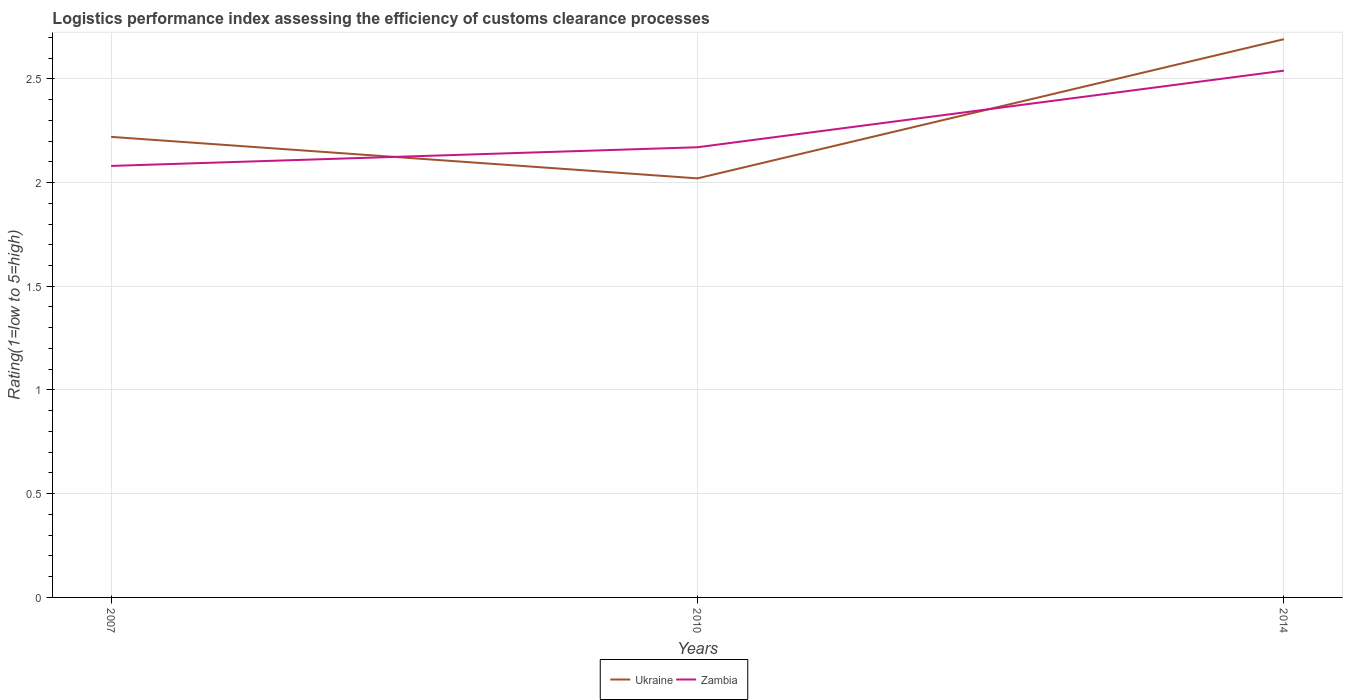How many different coloured lines are there?
Give a very brief answer. 2. Across all years, what is the maximum Logistic performance index in Ukraine?
Make the answer very short. 2.02. What is the total Logistic performance index in Zambia in the graph?
Provide a short and direct response. -0.46. What is the difference between the highest and the second highest Logistic performance index in Ukraine?
Provide a succinct answer. 0.67. What is the difference between the highest and the lowest Logistic performance index in Ukraine?
Offer a terse response. 1. Is the Logistic performance index in Zambia strictly greater than the Logistic performance index in Ukraine over the years?
Ensure brevity in your answer.  No. How many lines are there?
Make the answer very short. 2. How many years are there in the graph?
Give a very brief answer. 3. Does the graph contain any zero values?
Provide a short and direct response. No. Does the graph contain grids?
Ensure brevity in your answer.  Yes. Where does the legend appear in the graph?
Your response must be concise. Bottom center. How are the legend labels stacked?
Offer a terse response. Horizontal. What is the title of the graph?
Ensure brevity in your answer.  Logistics performance index assessing the efficiency of customs clearance processes. What is the label or title of the Y-axis?
Provide a short and direct response. Rating(1=low to 5=high). What is the Rating(1=low to 5=high) of Ukraine in 2007?
Your answer should be very brief. 2.22. What is the Rating(1=low to 5=high) in Zambia in 2007?
Your answer should be compact. 2.08. What is the Rating(1=low to 5=high) of Ukraine in 2010?
Provide a succinct answer. 2.02. What is the Rating(1=low to 5=high) in Zambia in 2010?
Offer a terse response. 2.17. What is the Rating(1=low to 5=high) of Ukraine in 2014?
Your answer should be very brief. 2.69. What is the Rating(1=low to 5=high) in Zambia in 2014?
Provide a short and direct response. 2.54. Across all years, what is the maximum Rating(1=low to 5=high) of Ukraine?
Provide a succinct answer. 2.69. Across all years, what is the maximum Rating(1=low to 5=high) of Zambia?
Your answer should be compact. 2.54. Across all years, what is the minimum Rating(1=low to 5=high) of Ukraine?
Provide a short and direct response. 2.02. Across all years, what is the minimum Rating(1=low to 5=high) in Zambia?
Offer a very short reply. 2.08. What is the total Rating(1=low to 5=high) in Ukraine in the graph?
Provide a short and direct response. 6.93. What is the total Rating(1=low to 5=high) of Zambia in the graph?
Your response must be concise. 6.79. What is the difference between the Rating(1=low to 5=high) of Ukraine in 2007 and that in 2010?
Offer a terse response. 0.2. What is the difference between the Rating(1=low to 5=high) in Zambia in 2007 and that in 2010?
Your answer should be very brief. -0.09. What is the difference between the Rating(1=low to 5=high) of Ukraine in 2007 and that in 2014?
Give a very brief answer. -0.47. What is the difference between the Rating(1=low to 5=high) of Zambia in 2007 and that in 2014?
Make the answer very short. -0.46. What is the difference between the Rating(1=low to 5=high) of Ukraine in 2010 and that in 2014?
Provide a short and direct response. -0.67. What is the difference between the Rating(1=low to 5=high) of Zambia in 2010 and that in 2014?
Give a very brief answer. -0.37. What is the difference between the Rating(1=low to 5=high) of Ukraine in 2007 and the Rating(1=low to 5=high) of Zambia in 2010?
Provide a short and direct response. 0.05. What is the difference between the Rating(1=low to 5=high) in Ukraine in 2007 and the Rating(1=low to 5=high) in Zambia in 2014?
Your response must be concise. -0.32. What is the difference between the Rating(1=low to 5=high) in Ukraine in 2010 and the Rating(1=low to 5=high) in Zambia in 2014?
Ensure brevity in your answer.  -0.52. What is the average Rating(1=low to 5=high) of Ukraine per year?
Ensure brevity in your answer.  2.31. What is the average Rating(1=low to 5=high) of Zambia per year?
Your answer should be compact. 2.26. In the year 2007, what is the difference between the Rating(1=low to 5=high) in Ukraine and Rating(1=low to 5=high) in Zambia?
Ensure brevity in your answer.  0.14. In the year 2014, what is the difference between the Rating(1=low to 5=high) in Ukraine and Rating(1=low to 5=high) in Zambia?
Your answer should be very brief. 0.15. What is the ratio of the Rating(1=low to 5=high) in Ukraine in 2007 to that in 2010?
Offer a terse response. 1.1. What is the ratio of the Rating(1=low to 5=high) of Zambia in 2007 to that in 2010?
Offer a terse response. 0.96. What is the ratio of the Rating(1=low to 5=high) of Ukraine in 2007 to that in 2014?
Your response must be concise. 0.82. What is the ratio of the Rating(1=low to 5=high) in Zambia in 2007 to that in 2014?
Offer a very short reply. 0.82. What is the ratio of the Rating(1=low to 5=high) of Ukraine in 2010 to that in 2014?
Make the answer very short. 0.75. What is the ratio of the Rating(1=low to 5=high) of Zambia in 2010 to that in 2014?
Your response must be concise. 0.85. What is the difference between the highest and the second highest Rating(1=low to 5=high) of Ukraine?
Provide a succinct answer. 0.47. What is the difference between the highest and the second highest Rating(1=low to 5=high) of Zambia?
Your response must be concise. 0.37. What is the difference between the highest and the lowest Rating(1=low to 5=high) in Ukraine?
Keep it short and to the point. 0.67. What is the difference between the highest and the lowest Rating(1=low to 5=high) of Zambia?
Provide a short and direct response. 0.46. 